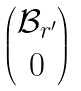<formula> <loc_0><loc_0><loc_500><loc_500>\begin{pmatrix} \mathcal { B } _ { r ^ { \prime } } \\ 0 \end{pmatrix}</formula> 